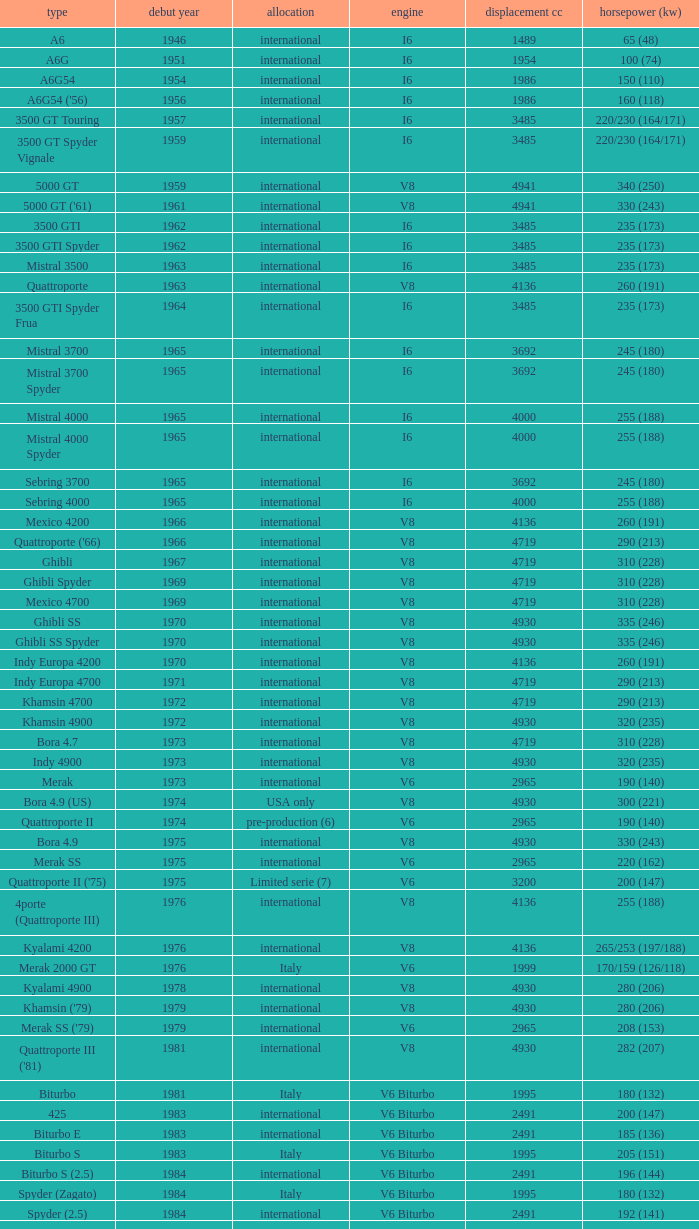Parse the full table. {'header': ['type', 'debut year', 'allocation', 'engine', 'displacement cc', 'horsepower (kw)'], 'rows': [['A6', '1946', 'international', 'I6', '1489', '65 (48)'], ['A6G', '1951', 'international', 'I6', '1954', '100 (74)'], ['A6G54', '1954', 'international', 'I6', '1986', '150 (110)'], ["A6G54 ('56)", '1956', 'international', 'I6', '1986', '160 (118)'], ['3500 GT Touring', '1957', 'international', 'I6', '3485', '220/230 (164/171)'], ['3500 GT Spyder Vignale', '1959', 'international', 'I6', '3485', '220/230 (164/171)'], ['5000 GT', '1959', 'international', 'V8', '4941', '340 (250)'], ["5000 GT ('61)", '1961', 'international', 'V8', '4941', '330 (243)'], ['3500 GTI', '1962', 'international', 'I6', '3485', '235 (173)'], ['3500 GTI Spyder', '1962', 'international', 'I6', '3485', '235 (173)'], ['Mistral 3500', '1963', 'international', 'I6', '3485', '235 (173)'], ['Quattroporte', '1963', 'international', 'V8', '4136', '260 (191)'], ['3500 GTI Spyder Frua', '1964', 'international', 'I6', '3485', '235 (173)'], ['Mistral 3700', '1965', 'international', 'I6', '3692', '245 (180)'], ['Mistral 3700 Spyder', '1965', 'international', 'I6', '3692', '245 (180)'], ['Mistral 4000', '1965', 'international', 'I6', '4000', '255 (188)'], ['Mistral 4000 Spyder', '1965', 'international', 'I6', '4000', '255 (188)'], ['Sebring 3700', '1965', 'international', 'I6', '3692', '245 (180)'], ['Sebring 4000', '1965', 'international', 'I6', '4000', '255 (188)'], ['Mexico 4200', '1966', 'international', 'V8', '4136', '260 (191)'], ["Quattroporte ('66)", '1966', 'international', 'V8', '4719', '290 (213)'], ['Ghibli', '1967', 'international', 'V8', '4719', '310 (228)'], ['Ghibli Spyder', '1969', 'international', 'V8', '4719', '310 (228)'], ['Mexico 4700', '1969', 'international', 'V8', '4719', '310 (228)'], ['Ghibli SS', '1970', 'international', 'V8', '4930', '335 (246)'], ['Ghibli SS Spyder', '1970', 'international', 'V8', '4930', '335 (246)'], ['Indy Europa 4200', '1970', 'international', 'V8', '4136', '260 (191)'], ['Indy Europa 4700', '1971', 'international', 'V8', '4719', '290 (213)'], ['Khamsin 4700', '1972', 'international', 'V8', '4719', '290 (213)'], ['Khamsin 4900', '1972', 'international', 'V8', '4930', '320 (235)'], ['Bora 4.7', '1973', 'international', 'V8', '4719', '310 (228)'], ['Indy 4900', '1973', 'international', 'V8', '4930', '320 (235)'], ['Merak', '1973', 'international', 'V6', '2965', '190 (140)'], ['Bora 4.9 (US)', '1974', 'USA only', 'V8', '4930', '300 (221)'], ['Quattroporte II', '1974', 'pre-production (6)', 'V6', '2965', '190 (140)'], ['Bora 4.9', '1975', 'international', 'V8', '4930', '330 (243)'], ['Merak SS', '1975', 'international', 'V6', '2965', '220 (162)'], ["Quattroporte II ('75)", '1975', 'Limited serie (7)', 'V6', '3200', '200 (147)'], ['4porte (Quattroporte III)', '1976', 'international', 'V8', '4136', '255 (188)'], ['Kyalami 4200', '1976', 'international', 'V8', '4136', '265/253 (197/188)'], ['Merak 2000 GT', '1976', 'Italy', 'V6', '1999', '170/159 (126/118)'], ['Kyalami 4900', '1978', 'international', 'V8', '4930', '280 (206)'], ["Khamsin ('79)", '1979', 'international', 'V8', '4930', '280 (206)'], ["Merak SS ('79)", '1979', 'international', 'V6', '2965', '208 (153)'], ["Quattroporte III ('81)", '1981', 'international', 'V8', '4930', '282 (207)'], ['Biturbo', '1981', 'Italy', 'V6 Biturbo', '1995', '180 (132)'], ['425', '1983', 'international', 'V6 Biturbo', '2491', '200 (147)'], ['Biturbo E', '1983', 'international', 'V6 Biturbo', '2491', '185 (136)'], ['Biturbo S', '1983', 'Italy', 'V6 Biturbo', '1995', '205 (151)'], ['Biturbo S (2.5)', '1984', 'international', 'V6 Biturbo', '2491', '196 (144)'], ['Spyder (Zagato)', '1984', 'Italy', 'V6 Biturbo', '1995', '180 (132)'], ['Spyder (2.5)', '1984', 'international', 'V6 Biturbo', '2491', '192 (141)'], ['420', '1985', 'Italy', 'V6 Biturbo', '1995', '180 (132)'], ['Biturbo (II)', '1985', 'Italy', 'V6 Biturbo', '1995', '180 (132)'], ['Biturbo E (II 2.5)', '1985', 'international', 'V6 Biturbo', '2491', '185 (136)'], ['Biturbo S (II)', '1985', 'Italy', 'V6 Biturbo', '1995', '210 (154)'], ['228 (228i)', '1986', 'international', 'V6 Biturbo', '2790', '250 (184)'], ['228 (228i) Kat', '1986', 'international', 'V6 Biturbo', '2790', '225 (165)'], ['420i', '1986', 'Italy', 'V6 Biturbo', '1995', '190 (140)'], ['420 S', '1986', 'Italy', 'V6 Biturbo', '1995', '210 (154)'], ['Biturbo i', '1986', 'Italy', 'V6 Biturbo', '1995', '185 (136)'], ['Quattroporte Royale (III)', '1986', 'international', 'V8', '4930', '300 (221)'], ['Spyder i', '1986', 'international', 'V6 Biturbo', '1996', '185 (136)'], ['430', '1987', 'international', 'V6 Biturbo', '2790', '225 (165)'], ['425i', '1987', 'international', 'V6 Biturbo', '2491', '188 (138)'], ['Biturbo Si', '1987', 'Italy', 'V6 Biturbo', '1995', '220 (162)'], ['Biturbo Si (2.5)', '1987', 'international', 'V6 Biturbo', '2491', '188 (138)'], ["Spyder i ('87)", '1987', 'international', 'V6 Biturbo', '1996', '195 (143)'], ['222', '1988', 'Italy', 'V6 Biturbo', '1996', '220 (162)'], ['422', '1988', 'Italy', 'V6 Biturbo', '1996', '220 (162)'], ['2.24V', '1988', 'Italy (probably)', 'V6 Biturbo', '1996', '245 (180)'], ['222 4v', '1988', 'international', 'V6 Biturbo', '2790', '279 (205)'], ['222 E', '1988', 'international', 'V6 Biturbo', '2790', '225 (165)'], ['Karif', '1988', 'international', 'V6 Biturbo', '2790', '285 (210)'], ['Karif (kat)', '1988', 'international', 'V6 Biturbo', '2790', '248 (182)'], ['Karif (kat II)', '1988', 'international', 'V6 Biturbo', '2790', '225 (165)'], ['Spyder i (2.5)', '1988', 'international', 'V6 Biturbo', '2491', '188 (138)'], ['Spyder i (2.8)', '1989', 'international', 'V6 Biturbo', '2790', '250 (184)'], ['Spyder i (2.8, kat)', '1989', 'international', 'V6 Biturbo', '2790', '225 (165)'], ["Spyder i ('90)", '1989', 'Italy', 'V6 Biturbo', '1996', '220 (162)'], ['222 SE', '1990', 'international', 'V6 Biturbo', '2790', '250 (184)'], ['222 SE (kat)', '1990', 'international', 'V6 Biturbo', '2790', '225 (165)'], ['4.18v', '1990', 'Italy', 'V6 Biturbo', '1995', '220 (162)'], ['4.24v', '1990', 'Italy (probably)', 'V6 Biturbo', '1996', '245 (180)'], ['Shamal', '1990', 'international', 'V8 Biturbo', '3217', '326 (240)'], ['2.24v II', '1991', 'Italy', 'V6 Biturbo', '1996', '245 (180)'], ['2.24v II (kat)', '1991', 'international (probably)', 'V6 Biturbo', '1996', '240 (176)'], ['222 SR', '1991', 'international', 'V6 Biturbo', '2790', '225 (165)'], ['4.24v II (kat)', '1991', 'Italy (probably)', 'V6 Biturbo', '1996', '240 (176)'], ['430 4v', '1991', 'international', 'V6 Biturbo', '2790', '279 (205)'], ['Racing', '1991', 'Italy', 'V6 Biturbo', '1996', '283 (208)'], ['Spyder III', '1991', 'Italy', 'V6 Biturbo', '1996', '245 (180)'], ['Spyder III (2.8, kat)', '1991', 'international', 'V6 Biturbo', '2790', '225 (165)'], ['Spyder III (kat)', '1991', 'Italy', 'V6 Biturbo', '1996', '240 (176)'], ['Barchetta Stradale', '1992', 'Prototype', 'V6 Biturbo', '1996', '306 (225)'], ['Barchetta Stradale 2.8', '1992', 'Single, Conversion', 'V6 Biturbo', '2790', '284 (209)'], ['Ghibli II (2.0)', '1992', 'Italy', 'V6 Biturbo', '1996', '306 (225)'], ['Ghibli II (2.8)', '1993', 'international', 'V6 Biturbo', '2790', '284 (209)'], ['Quattroporte (2.0)', '1994', 'Italy', 'V6 Biturbo', '1996', '287 (211)'], ['Quattroporte (2.8)', '1994', 'international', 'V6 Biturbo', '2790', '284 (209)'], ['Ghibli Cup', '1995', 'international', 'V6 Biturbo', '1996', '330 (243)'], ['Quattroporte Ottocilindri', '1995', 'international', 'V8 Biturbo', '3217', '335 (246)'], ['Ghibli Primatist', '1996', 'international', 'V6 Biturbo', '1996', '306 (225)'], ['3200 GT', '1998', 'international', 'V8 Biturbo', '3217', '370 (272)'], ['Quattroporte V6 Evoluzione', '1998', 'international', 'V6 Biturbo', '2790', '284 (209)'], ['Quattroporte V8 Evoluzione', '1998', 'international', 'V8 Biturbo', '3217', '335 (246)'], ['3200 GTA', '2000', 'international', 'V8 Biturbo', '3217', '368 (271)'], ['Spyder GT', '2001', 'international', 'V8', '4244', '390 (287)'], ['Spyder CC', '2001', 'international', 'V8', '4244', '390 (287)'], ['Coupé GT', '2001', 'international', 'V8', '4244', '390 (287)'], ['Coupé CC', '2001', 'international', 'V8', '4244', '390 (287)'], ['Gran Sport', '2002', 'international', 'V8', '4244', '400 (294)'], ['Quattroporte V', '2004', 'international', 'V8', '4244', '400 (294)'], ['MC12 (aka MCC)', '2004', 'Limited', 'V12', '5998', '630 (463)'], ['GranTurismo', '2008', 'international', 'V8', '4244', '405'], ['GranCabrio', '2010', 'international', 'V8', '4691', '433']]} What is the lowest First Year, when Model is "Quattroporte (2.8)"? 1994.0. 